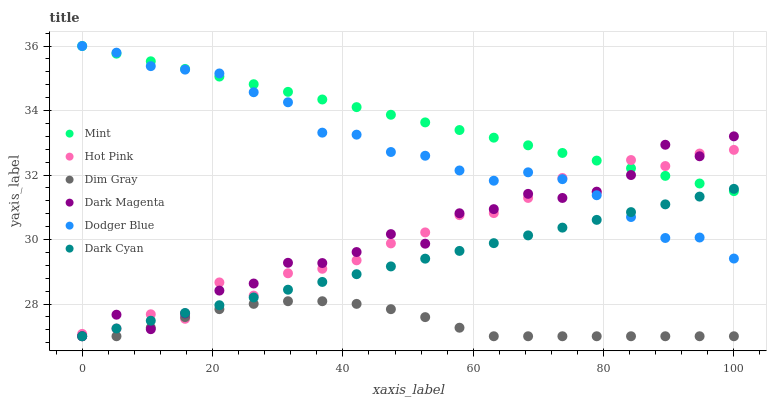Does Dim Gray have the minimum area under the curve?
Answer yes or no. Yes. Does Mint have the maximum area under the curve?
Answer yes or no. Yes. Does Dark Magenta have the minimum area under the curve?
Answer yes or no. No. Does Dark Magenta have the maximum area under the curve?
Answer yes or no. No. Is Dark Cyan the smoothest?
Answer yes or no. Yes. Is Hot Pink the roughest?
Answer yes or no. Yes. Is Dark Magenta the smoothest?
Answer yes or no. No. Is Dark Magenta the roughest?
Answer yes or no. No. Does Dim Gray have the lowest value?
Answer yes or no. Yes. Does Hot Pink have the lowest value?
Answer yes or no. No. Does Mint have the highest value?
Answer yes or no. Yes. Does Dark Magenta have the highest value?
Answer yes or no. No. Is Dim Gray less than Mint?
Answer yes or no. Yes. Is Mint greater than Dim Gray?
Answer yes or no. Yes. Does Dodger Blue intersect Mint?
Answer yes or no. Yes. Is Dodger Blue less than Mint?
Answer yes or no. No. Is Dodger Blue greater than Mint?
Answer yes or no. No. Does Dim Gray intersect Mint?
Answer yes or no. No. 